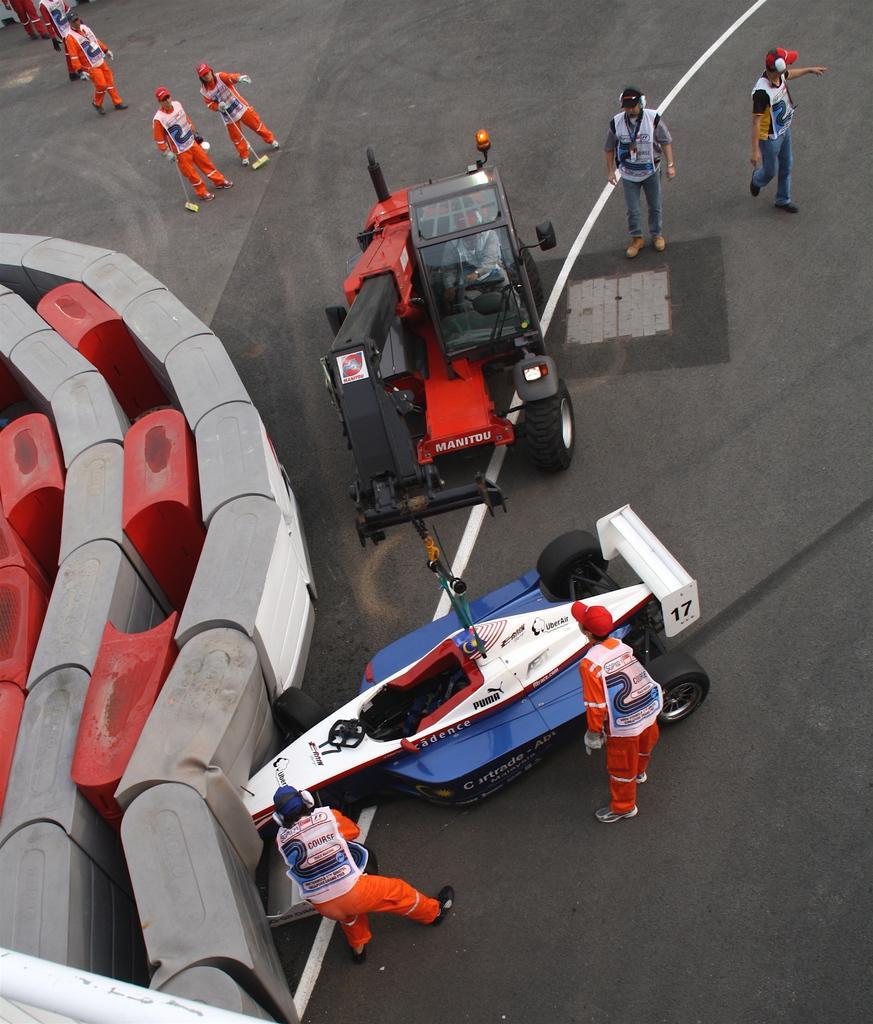Please provide a concise description of this image. In this image there are vehicles on the road and there are people standing on the road. On the left side of the image there is an object. 